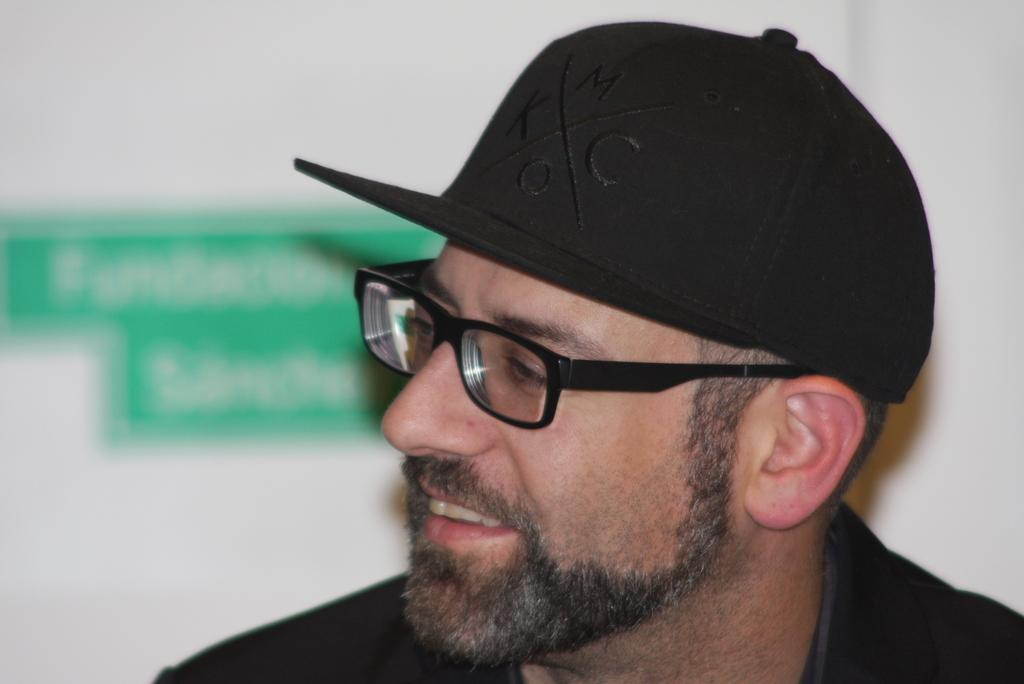Who is present in the image? There is a man in the image. What is the man wearing on his head? The man is wearing a black hat. What accessory is the man wearing on his face? The man is wearing spectacles. How is the background of the image depicted? The background of the man is blurred. What is the man's reaction to the wristwatch in the image? There is no wristwatch present in the image, so it is not possible to determine the man's reaction to it. 